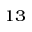Convert formula to latex. <formula><loc_0><loc_0><loc_500><loc_500>^ { 1 3 }</formula> 